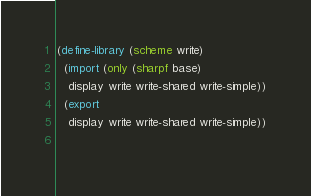Convert code to text. <code><loc_0><loc_0><loc_500><loc_500><_Scheme_>(define-library (scheme write)
  (import (only (sharpf base)
   display write write-shared write-simple))
  (export
   display write write-shared write-simple))
  
</code> 